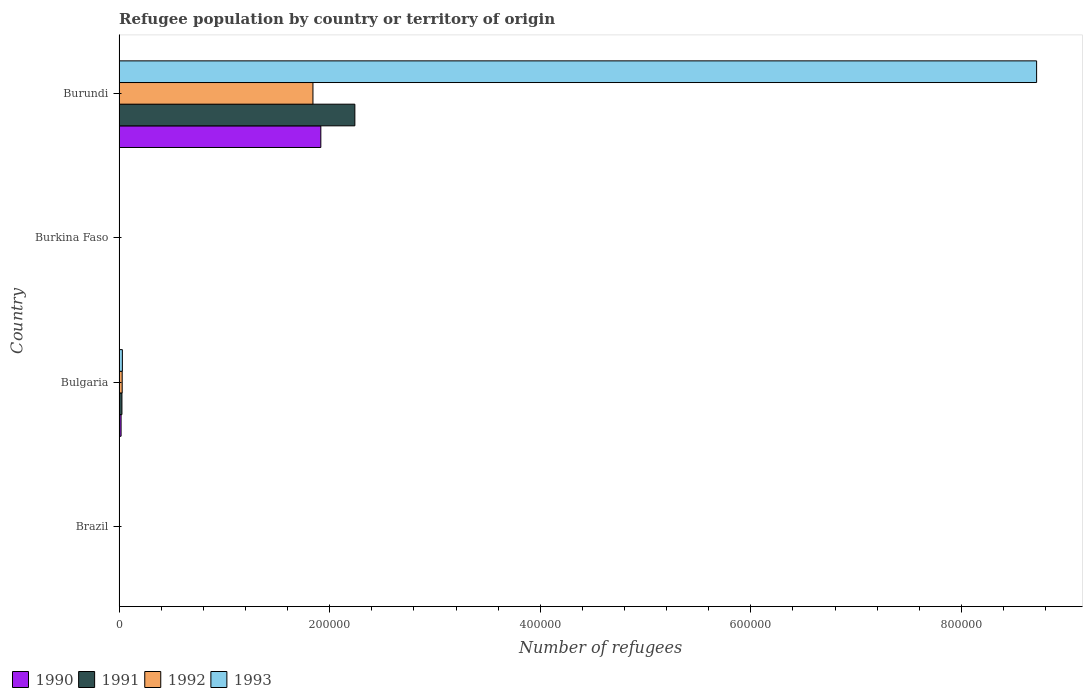How many different coloured bars are there?
Offer a very short reply. 4. How many groups of bars are there?
Provide a short and direct response. 4. Are the number of bars per tick equal to the number of legend labels?
Provide a short and direct response. Yes. How many bars are there on the 3rd tick from the top?
Provide a succinct answer. 4. What is the number of refugees in 1993 in Brazil?
Your answer should be compact. 12. Across all countries, what is the maximum number of refugees in 1990?
Provide a short and direct response. 1.92e+05. In which country was the number of refugees in 1990 maximum?
Make the answer very short. Burundi. In which country was the number of refugees in 1991 minimum?
Your answer should be compact. Burkina Faso. What is the total number of refugees in 1993 in the graph?
Give a very brief answer. 8.75e+05. What is the difference between the number of refugees in 1990 in Burundi and the number of refugees in 1993 in Brazil?
Keep it short and to the point. 1.92e+05. What is the average number of refugees in 1992 per country?
Your answer should be compact. 4.68e+04. What is the difference between the number of refugees in 1991 and number of refugees in 1990 in Burundi?
Provide a succinct answer. 3.23e+04. In how many countries, is the number of refugees in 1993 greater than 400000 ?
Your answer should be very brief. 1. What is the ratio of the number of refugees in 1992 in Brazil to that in Burkina Faso?
Provide a succinct answer. 0.18. What is the difference between the highest and the second highest number of refugees in 1991?
Offer a very short reply. 2.21e+05. What is the difference between the highest and the lowest number of refugees in 1992?
Offer a terse response. 1.84e+05. In how many countries, is the number of refugees in 1991 greater than the average number of refugees in 1991 taken over all countries?
Provide a succinct answer. 1. Is the sum of the number of refugees in 1992 in Burkina Faso and Burundi greater than the maximum number of refugees in 1990 across all countries?
Offer a terse response. No. Is it the case that in every country, the sum of the number of refugees in 1993 and number of refugees in 1990 is greater than the sum of number of refugees in 1992 and number of refugees in 1991?
Keep it short and to the point. No. What does the 3rd bar from the bottom in Burkina Faso represents?
Your answer should be very brief. 1992. Is it the case that in every country, the sum of the number of refugees in 1992 and number of refugees in 1991 is greater than the number of refugees in 1990?
Ensure brevity in your answer.  Yes. How many bars are there?
Provide a succinct answer. 16. How many countries are there in the graph?
Give a very brief answer. 4. What is the difference between two consecutive major ticks on the X-axis?
Your answer should be very brief. 2.00e+05. Does the graph contain any zero values?
Offer a terse response. No. Where does the legend appear in the graph?
Make the answer very short. Bottom left. How many legend labels are there?
Keep it short and to the point. 4. How are the legend labels stacked?
Offer a very short reply. Horizontal. What is the title of the graph?
Offer a very short reply. Refugee population by country or territory of origin. What is the label or title of the X-axis?
Your answer should be very brief. Number of refugees. What is the label or title of the Y-axis?
Offer a very short reply. Country. What is the Number of refugees of 1991 in Brazil?
Keep it short and to the point. 11. What is the Number of refugees of 1990 in Bulgaria?
Your answer should be very brief. 1922. What is the Number of refugees in 1991 in Bulgaria?
Keep it short and to the point. 2735. What is the Number of refugees in 1992 in Bulgaria?
Your answer should be very brief. 2981. What is the Number of refugees in 1993 in Bulgaria?
Your response must be concise. 3155. What is the Number of refugees in 1990 in Burkina Faso?
Ensure brevity in your answer.  2. What is the Number of refugees in 1991 in Burkina Faso?
Give a very brief answer. 8. What is the Number of refugees of 1992 in Burkina Faso?
Give a very brief answer. 61. What is the Number of refugees in 1990 in Burundi?
Ensure brevity in your answer.  1.92e+05. What is the Number of refugees in 1991 in Burundi?
Offer a very short reply. 2.24e+05. What is the Number of refugees of 1992 in Burundi?
Your response must be concise. 1.84e+05. What is the Number of refugees in 1993 in Burundi?
Give a very brief answer. 8.71e+05. Across all countries, what is the maximum Number of refugees of 1990?
Your response must be concise. 1.92e+05. Across all countries, what is the maximum Number of refugees of 1991?
Your answer should be very brief. 2.24e+05. Across all countries, what is the maximum Number of refugees of 1992?
Make the answer very short. 1.84e+05. Across all countries, what is the maximum Number of refugees of 1993?
Ensure brevity in your answer.  8.71e+05. Across all countries, what is the minimum Number of refugees of 1992?
Give a very brief answer. 11. What is the total Number of refugees in 1990 in the graph?
Provide a succinct answer. 1.94e+05. What is the total Number of refugees in 1991 in the graph?
Offer a terse response. 2.27e+05. What is the total Number of refugees in 1992 in the graph?
Ensure brevity in your answer.  1.87e+05. What is the total Number of refugees in 1993 in the graph?
Your answer should be very brief. 8.75e+05. What is the difference between the Number of refugees in 1990 in Brazil and that in Bulgaria?
Provide a short and direct response. -1908. What is the difference between the Number of refugees in 1991 in Brazil and that in Bulgaria?
Your response must be concise. -2724. What is the difference between the Number of refugees in 1992 in Brazil and that in Bulgaria?
Give a very brief answer. -2970. What is the difference between the Number of refugees of 1993 in Brazil and that in Bulgaria?
Your response must be concise. -3143. What is the difference between the Number of refugees of 1993 in Brazil and that in Burkina Faso?
Your response must be concise. -51. What is the difference between the Number of refugees in 1990 in Brazil and that in Burundi?
Offer a terse response. -1.92e+05. What is the difference between the Number of refugees in 1991 in Brazil and that in Burundi?
Provide a short and direct response. -2.24e+05. What is the difference between the Number of refugees of 1992 in Brazil and that in Burundi?
Provide a succinct answer. -1.84e+05. What is the difference between the Number of refugees of 1993 in Brazil and that in Burundi?
Provide a short and direct response. -8.71e+05. What is the difference between the Number of refugees in 1990 in Bulgaria and that in Burkina Faso?
Ensure brevity in your answer.  1920. What is the difference between the Number of refugees of 1991 in Bulgaria and that in Burkina Faso?
Your response must be concise. 2727. What is the difference between the Number of refugees of 1992 in Bulgaria and that in Burkina Faso?
Make the answer very short. 2920. What is the difference between the Number of refugees in 1993 in Bulgaria and that in Burkina Faso?
Provide a succinct answer. 3092. What is the difference between the Number of refugees of 1990 in Bulgaria and that in Burundi?
Your response must be concise. -1.90e+05. What is the difference between the Number of refugees in 1991 in Bulgaria and that in Burundi?
Offer a very short reply. -2.21e+05. What is the difference between the Number of refugees in 1992 in Bulgaria and that in Burundi?
Offer a very short reply. -1.81e+05. What is the difference between the Number of refugees in 1993 in Bulgaria and that in Burundi?
Your response must be concise. -8.68e+05. What is the difference between the Number of refugees in 1990 in Burkina Faso and that in Burundi?
Offer a terse response. -1.92e+05. What is the difference between the Number of refugees of 1991 in Burkina Faso and that in Burundi?
Offer a terse response. -2.24e+05. What is the difference between the Number of refugees of 1992 in Burkina Faso and that in Burundi?
Provide a short and direct response. -1.84e+05. What is the difference between the Number of refugees of 1993 in Burkina Faso and that in Burundi?
Provide a succinct answer. -8.71e+05. What is the difference between the Number of refugees in 1990 in Brazil and the Number of refugees in 1991 in Bulgaria?
Offer a terse response. -2721. What is the difference between the Number of refugees of 1990 in Brazil and the Number of refugees of 1992 in Bulgaria?
Keep it short and to the point. -2967. What is the difference between the Number of refugees of 1990 in Brazil and the Number of refugees of 1993 in Bulgaria?
Your answer should be compact. -3141. What is the difference between the Number of refugees in 1991 in Brazil and the Number of refugees in 1992 in Bulgaria?
Provide a short and direct response. -2970. What is the difference between the Number of refugees of 1991 in Brazil and the Number of refugees of 1993 in Bulgaria?
Give a very brief answer. -3144. What is the difference between the Number of refugees in 1992 in Brazil and the Number of refugees in 1993 in Bulgaria?
Keep it short and to the point. -3144. What is the difference between the Number of refugees of 1990 in Brazil and the Number of refugees of 1992 in Burkina Faso?
Give a very brief answer. -47. What is the difference between the Number of refugees of 1990 in Brazil and the Number of refugees of 1993 in Burkina Faso?
Provide a succinct answer. -49. What is the difference between the Number of refugees of 1991 in Brazil and the Number of refugees of 1992 in Burkina Faso?
Keep it short and to the point. -50. What is the difference between the Number of refugees of 1991 in Brazil and the Number of refugees of 1993 in Burkina Faso?
Ensure brevity in your answer.  -52. What is the difference between the Number of refugees of 1992 in Brazil and the Number of refugees of 1993 in Burkina Faso?
Keep it short and to the point. -52. What is the difference between the Number of refugees of 1990 in Brazil and the Number of refugees of 1991 in Burundi?
Your answer should be compact. -2.24e+05. What is the difference between the Number of refugees in 1990 in Brazil and the Number of refugees in 1992 in Burundi?
Offer a very short reply. -1.84e+05. What is the difference between the Number of refugees in 1990 in Brazil and the Number of refugees in 1993 in Burundi?
Your answer should be compact. -8.71e+05. What is the difference between the Number of refugees in 1991 in Brazil and the Number of refugees in 1992 in Burundi?
Give a very brief answer. -1.84e+05. What is the difference between the Number of refugees of 1991 in Brazil and the Number of refugees of 1993 in Burundi?
Your response must be concise. -8.71e+05. What is the difference between the Number of refugees of 1992 in Brazil and the Number of refugees of 1993 in Burundi?
Provide a succinct answer. -8.71e+05. What is the difference between the Number of refugees in 1990 in Bulgaria and the Number of refugees in 1991 in Burkina Faso?
Keep it short and to the point. 1914. What is the difference between the Number of refugees of 1990 in Bulgaria and the Number of refugees of 1992 in Burkina Faso?
Ensure brevity in your answer.  1861. What is the difference between the Number of refugees in 1990 in Bulgaria and the Number of refugees in 1993 in Burkina Faso?
Make the answer very short. 1859. What is the difference between the Number of refugees in 1991 in Bulgaria and the Number of refugees in 1992 in Burkina Faso?
Ensure brevity in your answer.  2674. What is the difference between the Number of refugees of 1991 in Bulgaria and the Number of refugees of 1993 in Burkina Faso?
Keep it short and to the point. 2672. What is the difference between the Number of refugees in 1992 in Bulgaria and the Number of refugees in 1993 in Burkina Faso?
Keep it short and to the point. 2918. What is the difference between the Number of refugees of 1990 in Bulgaria and the Number of refugees of 1991 in Burundi?
Give a very brief answer. -2.22e+05. What is the difference between the Number of refugees of 1990 in Bulgaria and the Number of refugees of 1992 in Burundi?
Provide a succinct answer. -1.82e+05. What is the difference between the Number of refugees of 1990 in Bulgaria and the Number of refugees of 1993 in Burundi?
Make the answer very short. -8.69e+05. What is the difference between the Number of refugees of 1991 in Bulgaria and the Number of refugees of 1992 in Burundi?
Give a very brief answer. -1.81e+05. What is the difference between the Number of refugees of 1991 in Bulgaria and the Number of refugees of 1993 in Burundi?
Make the answer very short. -8.69e+05. What is the difference between the Number of refugees in 1992 in Bulgaria and the Number of refugees in 1993 in Burundi?
Make the answer very short. -8.68e+05. What is the difference between the Number of refugees of 1990 in Burkina Faso and the Number of refugees of 1991 in Burundi?
Your answer should be compact. -2.24e+05. What is the difference between the Number of refugees of 1990 in Burkina Faso and the Number of refugees of 1992 in Burundi?
Keep it short and to the point. -1.84e+05. What is the difference between the Number of refugees of 1990 in Burkina Faso and the Number of refugees of 1993 in Burundi?
Ensure brevity in your answer.  -8.71e+05. What is the difference between the Number of refugees in 1991 in Burkina Faso and the Number of refugees in 1992 in Burundi?
Offer a very short reply. -1.84e+05. What is the difference between the Number of refugees of 1991 in Burkina Faso and the Number of refugees of 1993 in Burundi?
Offer a terse response. -8.71e+05. What is the difference between the Number of refugees of 1992 in Burkina Faso and the Number of refugees of 1993 in Burundi?
Offer a terse response. -8.71e+05. What is the average Number of refugees of 1990 per country?
Provide a succinct answer. 4.84e+04. What is the average Number of refugees of 1991 per country?
Offer a very short reply. 5.67e+04. What is the average Number of refugees in 1992 per country?
Give a very brief answer. 4.68e+04. What is the average Number of refugees in 1993 per country?
Your answer should be compact. 2.19e+05. What is the difference between the Number of refugees in 1990 and Number of refugees in 1992 in Brazil?
Your answer should be compact. 3. What is the difference between the Number of refugees of 1991 and Number of refugees of 1992 in Brazil?
Provide a succinct answer. 0. What is the difference between the Number of refugees of 1992 and Number of refugees of 1993 in Brazil?
Provide a succinct answer. -1. What is the difference between the Number of refugees in 1990 and Number of refugees in 1991 in Bulgaria?
Provide a short and direct response. -813. What is the difference between the Number of refugees in 1990 and Number of refugees in 1992 in Bulgaria?
Your answer should be compact. -1059. What is the difference between the Number of refugees of 1990 and Number of refugees of 1993 in Bulgaria?
Offer a very short reply. -1233. What is the difference between the Number of refugees of 1991 and Number of refugees of 1992 in Bulgaria?
Offer a very short reply. -246. What is the difference between the Number of refugees in 1991 and Number of refugees in 1993 in Bulgaria?
Your answer should be compact. -420. What is the difference between the Number of refugees of 1992 and Number of refugees of 1993 in Bulgaria?
Your answer should be compact. -174. What is the difference between the Number of refugees in 1990 and Number of refugees in 1992 in Burkina Faso?
Make the answer very short. -59. What is the difference between the Number of refugees of 1990 and Number of refugees of 1993 in Burkina Faso?
Your answer should be very brief. -61. What is the difference between the Number of refugees of 1991 and Number of refugees of 1992 in Burkina Faso?
Give a very brief answer. -53. What is the difference between the Number of refugees in 1991 and Number of refugees in 1993 in Burkina Faso?
Offer a terse response. -55. What is the difference between the Number of refugees in 1992 and Number of refugees in 1993 in Burkina Faso?
Your answer should be very brief. -2. What is the difference between the Number of refugees in 1990 and Number of refugees in 1991 in Burundi?
Keep it short and to the point. -3.23e+04. What is the difference between the Number of refugees in 1990 and Number of refugees in 1992 in Burundi?
Keep it short and to the point. 7487. What is the difference between the Number of refugees of 1990 and Number of refugees of 1993 in Burundi?
Your answer should be compact. -6.80e+05. What is the difference between the Number of refugees in 1991 and Number of refugees in 1992 in Burundi?
Offer a terse response. 3.98e+04. What is the difference between the Number of refugees of 1991 and Number of refugees of 1993 in Burundi?
Offer a very short reply. -6.47e+05. What is the difference between the Number of refugees of 1992 and Number of refugees of 1993 in Burundi?
Make the answer very short. -6.87e+05. What is the ratio of the Number of refugees in 1990 in Brazil to that in Bulgaria?
Provide a succinct answer. 0.01. What is the ratio of the Number of refugees of 1991 in Brazil to that in Bulgaria?
Provide a short and direct response. 0. What is the ratio of the Number of refugees in 1992 in Brazil to that in Bulgaria?
Provide a succinct answer. 0. What is the ratio of the Number of refugees in 1993 in Brazil to that in Bulgaria?
Offer a very short reply. 0. What is the ratio of the Number of refugees of 1991 in Brazil to that in Burkina Faso?
Offer a very short reply. 1.38. What is the ratio of the Number of refugees in 1992 in Brazil to that in Burkina Faso?
Provide a short and direct response. 0.18. What is the ratio of the Number of refugees in 1993 in Brazil to that in Burkina Faso?
Your response must be concise. 0.19. What is the ratio of the Number of refugees of 1991 in Brazil to that in Burundi?
Offer a very short reply. 0. What is the ratio of the Number of refugees in 1993 in Brazil to that in Burundi?
Ensure brevity in your answer.  0. What is the ratio of the Number of refugees of 1990 in Bulgaria to that in Burkina Faso?
Ensure brevity in your answer.  961. What is the ratio of the Number of refugees in 1991 in Bulgaria to that in Burkina Faso?
Your response must be concise. 341.88. What is the ratio of the Number of refugees of 1992 in Bulgaria to that in Burkina Faso?
Provide a succinct answer. 48.87. What is the ratio of the Number of refugees of 1993 in Bulgaria to that in Burkina Faso?
Offer a very short reply. 50.08. What is the ratio of the Number of refugees of 1991 in Bulgaria to that in Burundi?
Provide a succinct answer. 0.01. What is the ratio of the Number of refugees in 1992 in Bulgaria to that in Burundi?
Give a very brief answer. 0.02. What is the ratio of the Number of refugees of 1993 in Bulgaria to that in Burundi?
Give a very brief answer. 0. What is the ratio of the Number of refugees in 1990 in Burkina Faso to that in Burundi?
Offer a very short reply. 0. What is the ratio of the Number of refugees of 1991 in Burkina Faso to that in Burundi?
Provide a short and direct response. 0. What is the ratio of the Number of refugees of 1992 in Burkina Faso to that in Burundi?
Your answer should be very brief. 0. What is the difference between the highest and the second highest Number of refugees of 1990?
Your response must be concise. 1.90e+05. What is the difference between the highest and the second highest Number of refugees of 1991?
Make the answer very short. 2.21e+05. What is the difference between the highest and the second highest Number of refugees of 1992?
Your answer should be very brief. 1.81e+05. What is the difference between the highest and the second highest Number of refugees of 1993?
Provide a succinct answer. 8.68e+05. What is the difference between the highest and the lowest Number of refugees in 1990?
Ensure brevity in your answer.  1.92e+05. What is the difference between the highest and the lowest Number of refugees of 1991?
Offer a very short reply. 2.24e+05. What is the difference between the highest and the lowest Number of refugees of 1992?
Offer a terse response. 1.84e+05. What is the difference between the highest and the lowest Number of refugees in 1993?
Offer a very short reply. 8.71e+05. 